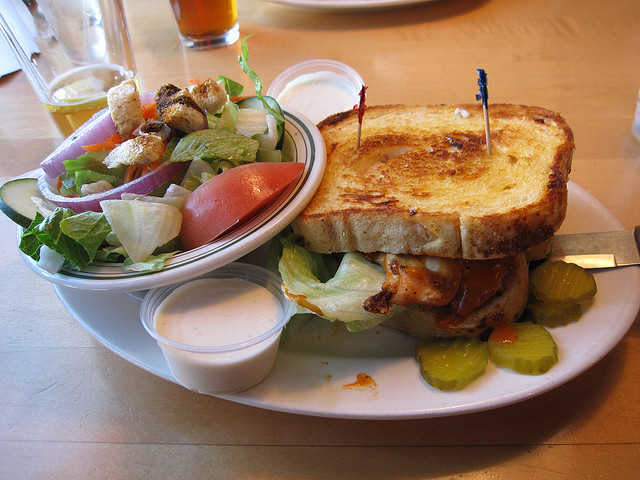<image>What brand of beer is on the table? I don't know what brand of beer is on the table. It can be Bud, Budweiser, Coors, Miller, or Heineken. What kind of bread is that? I don't know what kind of bread it is. It could be garlic, toast, white, french or wheat bread. What kind of bread is that? I am not sure what kind of bread it is. It can be garlic, toast, white, french or wheat bread. What brand of beer is on the table? I am not sure what brand of beer is on the table. It could be 'unknown', 'no clue', 'bud', 'budweiser', 'coors', 'miller', 'coors', 'bud', 'none', or 'heineken'. 